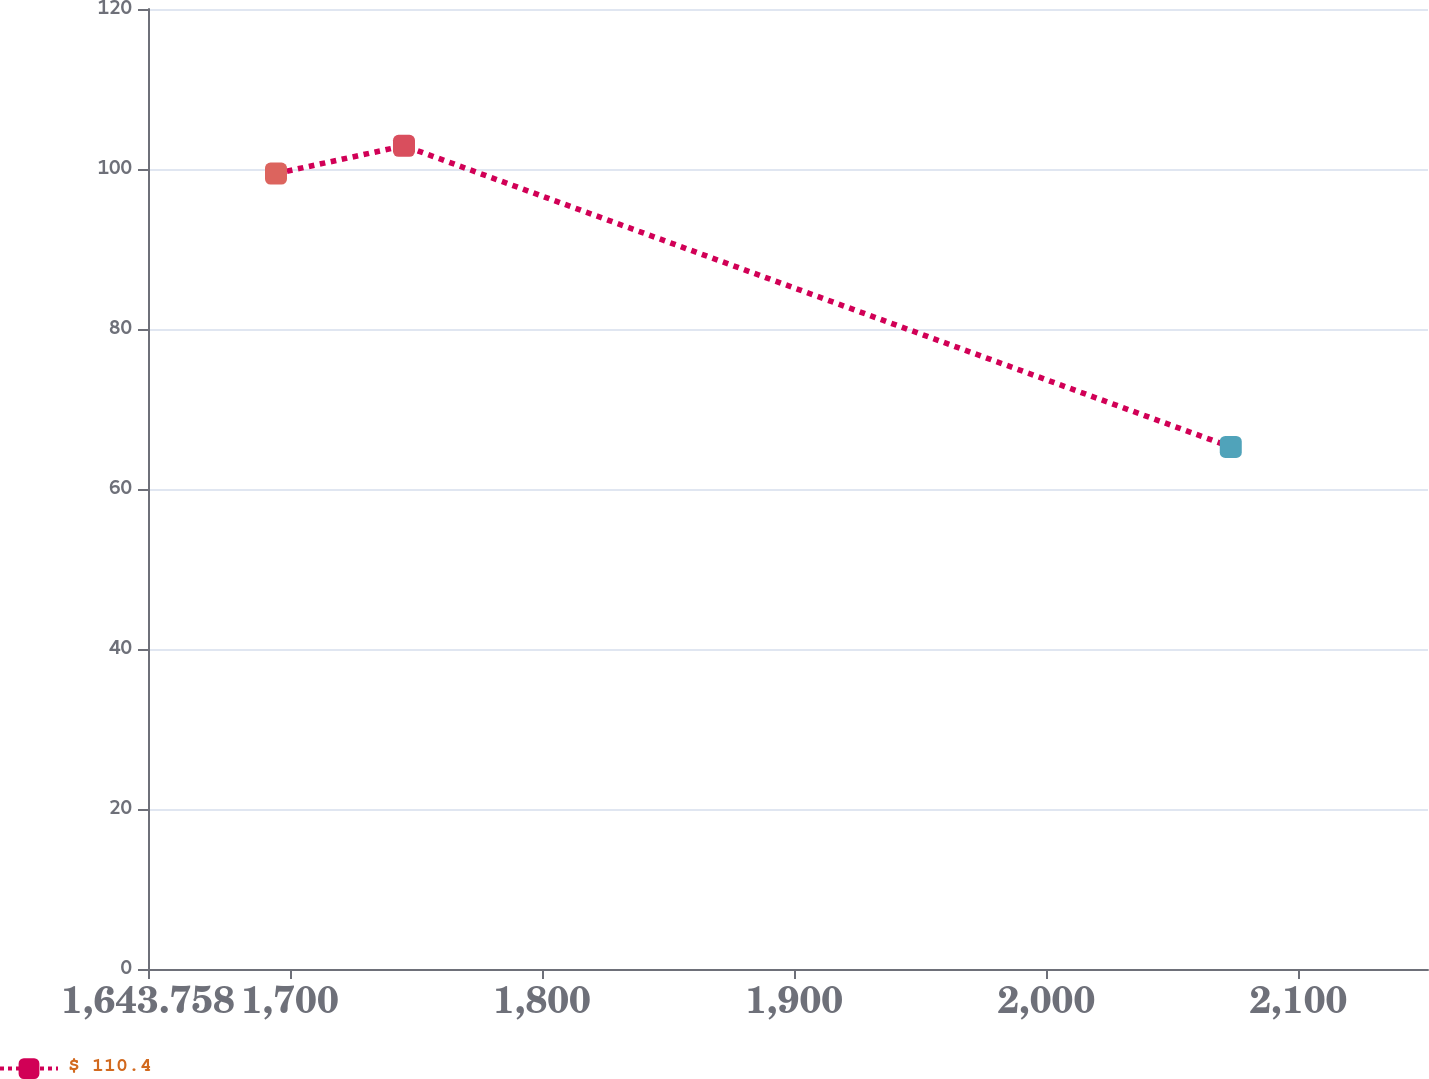Convert chart. <chart><loc_0><loc_0><loc_500><loc_500><line_chart><ecel><fcel>$ 110.4<nl><fcel>1694.52<fcel>99.43<nl><fcel>1745.28<fcel>102.9<nl><fcel>2073.16<fcel>65.26<nl><fcel>2202.14<fcel>85.9<nl></chart> 